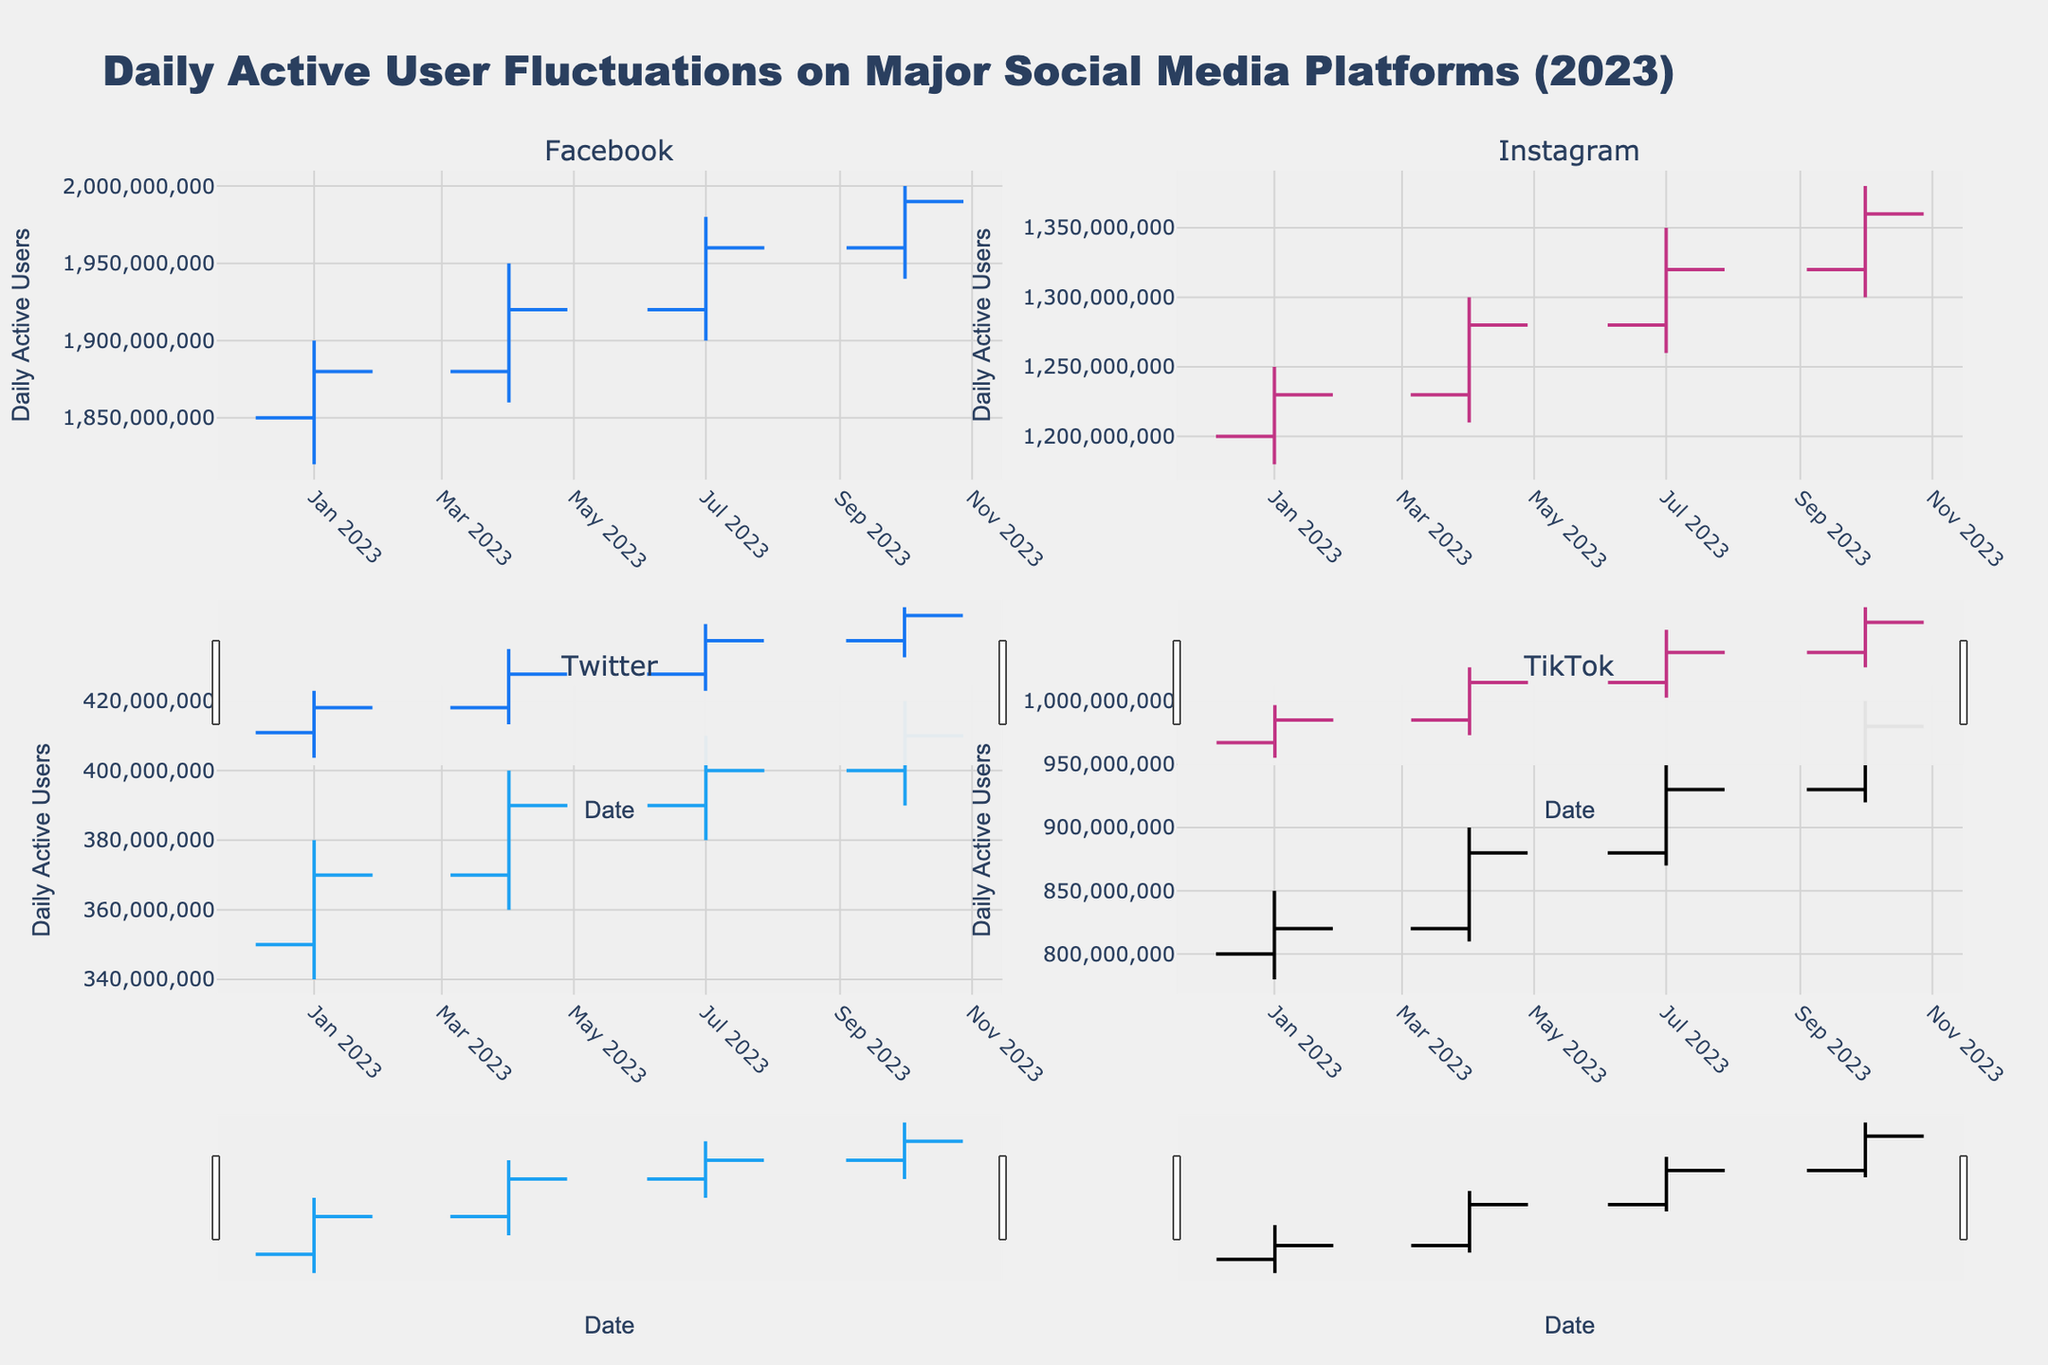How many platforms are visualized in the figure? There are four subplots, each representing a different platform: Facebook, Instagram, Twitter, and TikTok. Each subplot title corresponds to one of these platforms.
Answer: 4 Which platform had the highest daily active users in October 2023? By looking at the high values in the OHLC chart for October 2023, Facebook has the highest daily active users with a peak of 2,000,000,000.
Answer: Facebook What is the overall trend in daily active users for Instagram from January to October 2023? By examining the closing values for Instagram over the months (1,230,000,000 in January, 1,280,000,000 in April, 1,320,000,000 in July, and 1,360,000,000 in October), we observe an increasing trend.
Answer: Increasing Which platform shows the greatest variability in daily active users? The variability is assessed by the range between high and low values. TikTok in October 2023 shows the greatest variability, with a high of 1,000,000,000 and a low of 920,000,000, a range of 80,000,000.
Answer: TikTok Between April and July 2023, which platform had the largest increase in daily active users based on closing values? Calculating the differences between the closing values for April and July 2023: 
   - Facebook: 1,960,000,000 - 1,920,000,000 = 40,000,000
   - Instagram: 1,320,000,000 - 1,280,000,000 = 40,000,000  
   - Twitter: 400,000,000 - 390,000,000 = 10,000,000 
   - TikTok: 930,000,000 - 880,000,000 = 50,000,000 
   The largest increase is for TikTok with 50,000,000.
Answer: TikTok What is the closing value for Twitter in July 2023? The closing value for Twitter can be directly read from the OHLC chart in the subplot titled "Twitter." For July 2023, the closing value is 400,000,000 daily active users.
Answer: 400,000,000 How does TikTok's daily active user variability compare from January to October 2023? Comparing the ranges:
   - January: (850,000,000 - 780,000,000) = 70,000,000
   - April: (900,000,000 - 810,000,000) = 90,000,000
   - July: (950,000,000 - 870,000,000) = 80,000,000
   - October: (1,000,000,000 - 920,000,000) = 80,000,000
   TikTok shows relatively high variability each quarter, with the largest range in April (90,000,000), but consistently high variability throughout the period.
Answer: Consistent high variability Which month had the least fluctuation in closing values across all platforms? To find the month with the least fluctuation, we observe the closing values for each platform for each month. Calculate the range of closing values for each month:
   - January: max(1,880,000,000, 1,230,000,000, 370,000,000, 820,000,000) - min(1,880,000,000, 1,230,000,000, 370,000,000, 820,000,000) = 1,510,000,000
   - April: max(1,920,000,000, 1,280,000,000, 390,000,000, 880,000,000) - min(1,920,000,000, 1,280,000,000, 390,000,000, 880,000,000) = 1,530,000,000
   - July: max(1,960,000,000, 1,320,000,000, 400,000,000, 930,000,000) - min(1,960,000,000, 1,320,000,000, 400,000,000, 930,000,000) = 1,560,000,000
   - October: max(1,990,000,000, 1,360,000,000, 410,000,000, 980,000,000) - min(1,990,000,000, 1,360,000,000, 410,000,000, 980,000,000) = 1,580,000,000
   January has the least fluctuation of 1,510,000,000 amongst all platforms.
Answer: January Which platform had the highest closing value in July 2023? By examining the closing values in the July 2023 column of the OHLC charts, Facebook had the highest closing value with 1,960,000,000 daily active users.
Answer: Facebook 